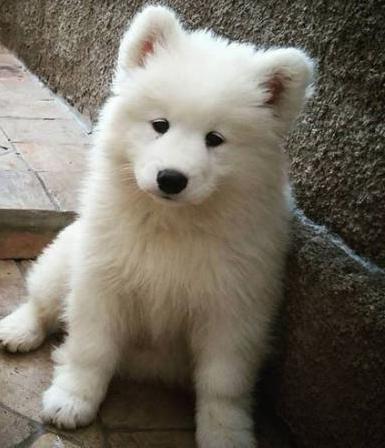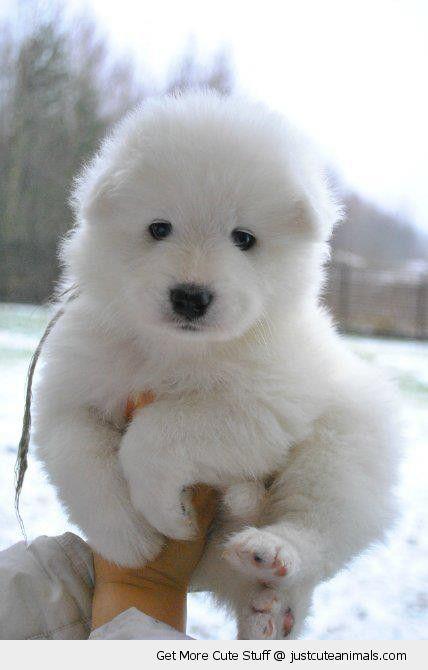The first image is the image on the left, the second image is the image on the right. Evaluate the accuracy of this statement regarding the images: "There are at most two dogs.". Is it true? Answer yes or no. Yes. The first image is the image on the left, the second image is the image on the right. Analyze the images presented: Is the assertion "One image contains twice as many white puppies as the other image and features puppies with their heads touching." valid? Answer yes or no. No. 